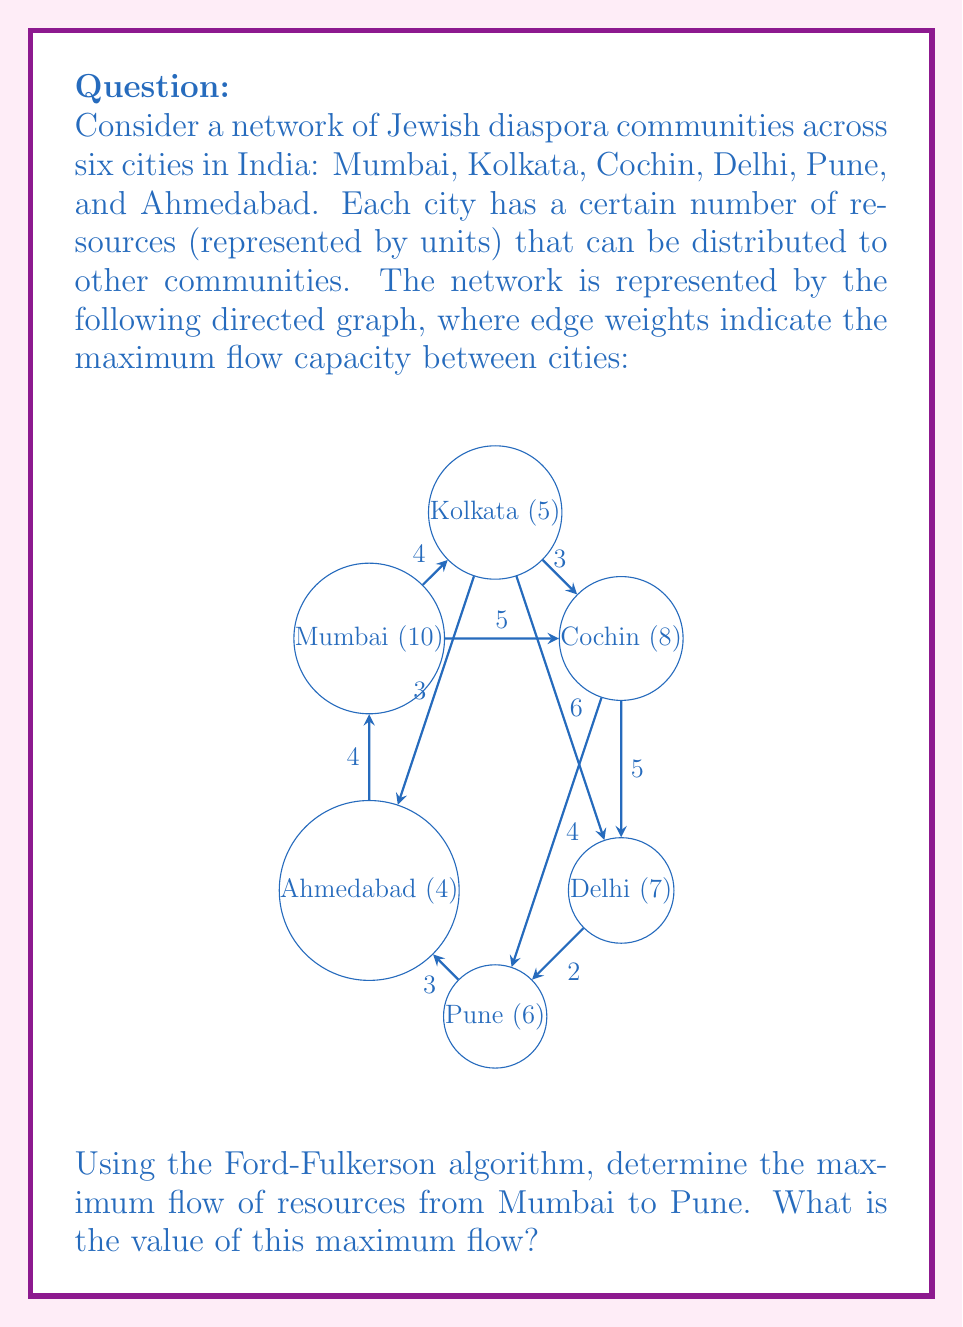Provide a solution to this math problem. To solve this problem using the Ford-Fulkerson algorithm, we'll follow these steps:

1) Initialize the flow to 0 for all edges.

2) Find an augmenting path from Mumbai to Pune using depth-first search (DFS) or breadth-first search (BFS). We'll use DFS here.

3) Augment the flow along the path found.

4) Repeat steps 2 and 3 until no more augmenting paths can be found.

Let's go through the iterations:

Iteration 1:
Path: Mumbai -> Kolkata -> Delhi -> Pune
Bottleneck capacity: min(4, 6, 2) = 2
Flow after augmentation: 2

Iteration 2:
Path: Mumbai -> Cochin -> Pune
Bottleneck capacity: min(5, 4) = 4
Flow after augmentation: 2 + 4 = 6

Iteration 3:
Path: Mumbai -> Ahmedabad -> Kolkata -> Delhi -> Pune
Bottleneck capacity: min(4, 3, 4, 2) = 2
Flow after augmentation: 6 + 2 = 8

No more augmenting paths can be found.

The maximum flow is the sum of all augmentations: 2 + 4 + 2 = 8.

We can verify this result by looking at the minimum cut in the graph. The minimum cut separates Mumbai, Ahmedabad, Kolkata, and Cochin from Delhi and Pune. The capacity of this cut is indeed 8 (5 from Cochin to Delhi, 2 from Delhi to Pune, and 1 remaining from Kolkata to Delhi).

Therefore, the maximum flow of resources from Mumbai to Pune is 8 units.
Answer: 8 units 